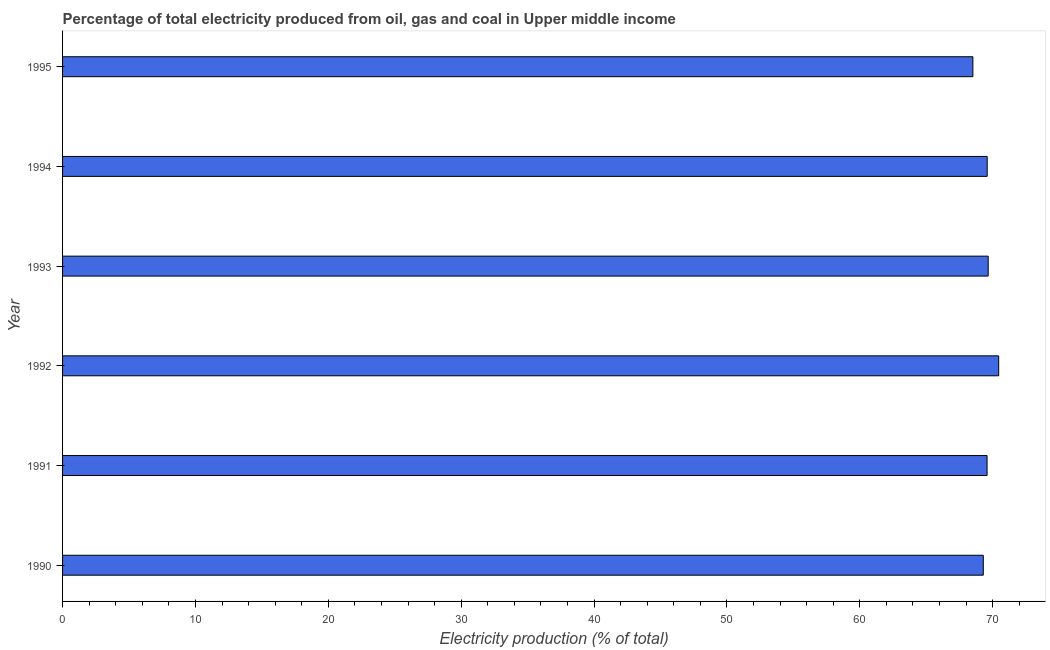Does the graph contain any zero values?
Ensure brevity in your answer.  No. Does the graph contain grids?
Make the answer very short. No. What is the title of the graph?
Ensure brevity in your answer.  Percentage of total electricity produced from oil, gas and coal in Upper middle income. What is the label or title of the X-axis?
Your answer should be very brief. Electricity production (% of total). What is the electricity production in 1992?
Your response must be concise. 70.46. Across all years, what is the maximum electricity production?
Keep it short and to the point. 70.46. Across all years, what is the minimum electricity production?
Give a very brief answer. 68.52. What is the sum of the electricity production?
Provide a succinct answer. 417.14. What is the difference between the electricity production in 1991 and 1995?
Provide a succinct answer. 1.07. What is the average electricity production per year?
Keep it short and to the point. 69.52. What is the median electricity production?
Provide a succinct answer. 69.59. Do a majority of the years between 1991 and 1995 (inclusive) have electricity production greater than 62 %?
Your answer should be compact. Yes. What is the ratio of the electricity production in 1993 to that in 1995?
Make the answer very short. 1.02. What is the difference between the highest and the second highest electricity production?
Keep it short and to the point. 0.79. Is the sum of the electricity production in 1992 and 1995 greater than the maximum electricity production across all years?
Keep it short and to the point. Yes. What is the difference between the highest and the lowest electricity production?
Offer a very short reply. 1.94. In how many years, is the electricity production greater than the average electricity production taken over all years?
Provide a short and direct response. 4. Are all the bars in the graph horizontal?
Your answer should be compact. Yes. How many years are there in the graph?
Your answer should be very brief. 6. Are the values on the major ticks of X-axis written in scientific E-notation?
Keep it short and to the point. No. What is the Electricity production (% of total) of 1990?
Provide a succinct answer. 69.3. What is the Electricity production (% of total) in 1991?
Make the answer very short. 69.59. What is the Electricity production (% of total) of 1992?
Make the answer very short. 70.46. What is the Electricity production (% of total) in 1993?
Keep it short and to the point. 69.67. What is the Electricity production (% of total) of 1994?
Provide a short and direct response. 69.6. What is the Electricity production (% of total) in 1995?
Offer a very short reply. 68.52. What is the difference between the Electricity production (% of total) in 1990 and 1991?
Ensure brevity in your answer.  -0.28. What is the difference between the Electricity production (% of total) in 1990 and 1992?
Your response must be concise. -1.16. What is the difference between the Electricity production (% of total) in 1990 and 1993?
Your answer should be very brief. -0.37. What is the difference between the Electricity production (% of total) in 1990 and 1994?
Provide a short and direct response. -0.29. What is the difference between the Electricity production (% of total) in 1990 and 1995?
Offer a very short reply. 0.78. What is the difference between the Electricity production (% of total) in 1991 and 1992?
Keep it short and to the point. -0.87. What is the difference between the Electricity production (% of total) in 1991 and 1993?
Make the answer very short. -0.08. What is the difference between the Electricity production (% of total) in 1991 and 1994?
Provide a succinct answer. -0.01. What is the difference between the Electricity production (% of total) in 1991 and 1995?
Your response must be concise. 1.07. What is the difference between the Electricity production (% of total) in 1992 and 1993?
Keep it short and to the point. 0.79. What is the difference between the Electricity production (% of total) in 1992 and 1994?
Keep it short and to the point. 0.86. What is the difference between the Electricity production (% of total) in 1992 and 1995?
Your answer should be very brief. 1.94. What is the difference between the Electricity production (% of total) in 1993 and 1994?
Your answer should be compact. 0.07. What is the difference between the Electricity production (% of total) in 1993 and 1995?
Provide a short and direct response. 1.15. What is the difference between the Electricity production (% of total) in 1994 and 1995?
Ensure brevity in your answer.  1.08. What is the ratio of the Electricity production (% of total) in 1990 to that in 1993?
Your answer should be compact. 0.99. What is the ratio of the Electricity production (% of total) in 1990 to that in 1994?
Make the answer very short. 1. What is the ratio of the Electricity production (% of total) in 1991 to that in 1992?
Make the answer very short. 0.99. What is the ratio of the Electricity production (% of total) in 1991 to that in 1993?
Give a very brief answer. 1. What is the ratio of the Electricity production (% of total) in 1991 to that in 1994?
Keep it short and to the point. 1. What is the ratio of the Electricity production (% of total) in 1992 to that in 1994?
Keep it short and to the point. 1.01. What is the ratio of the Electricity production (% of total) in 1992 to that in 1995?
Offer a very short reply. 1.03. What is the ratio of the Electricity production (% of total) in 1993 to that in 1994?
Ensure brevity in your answer.  1. What is the ratio of the Electricity production (% of total) in 1994 to that in 1995?
Give a very brief answer. 1.02. 